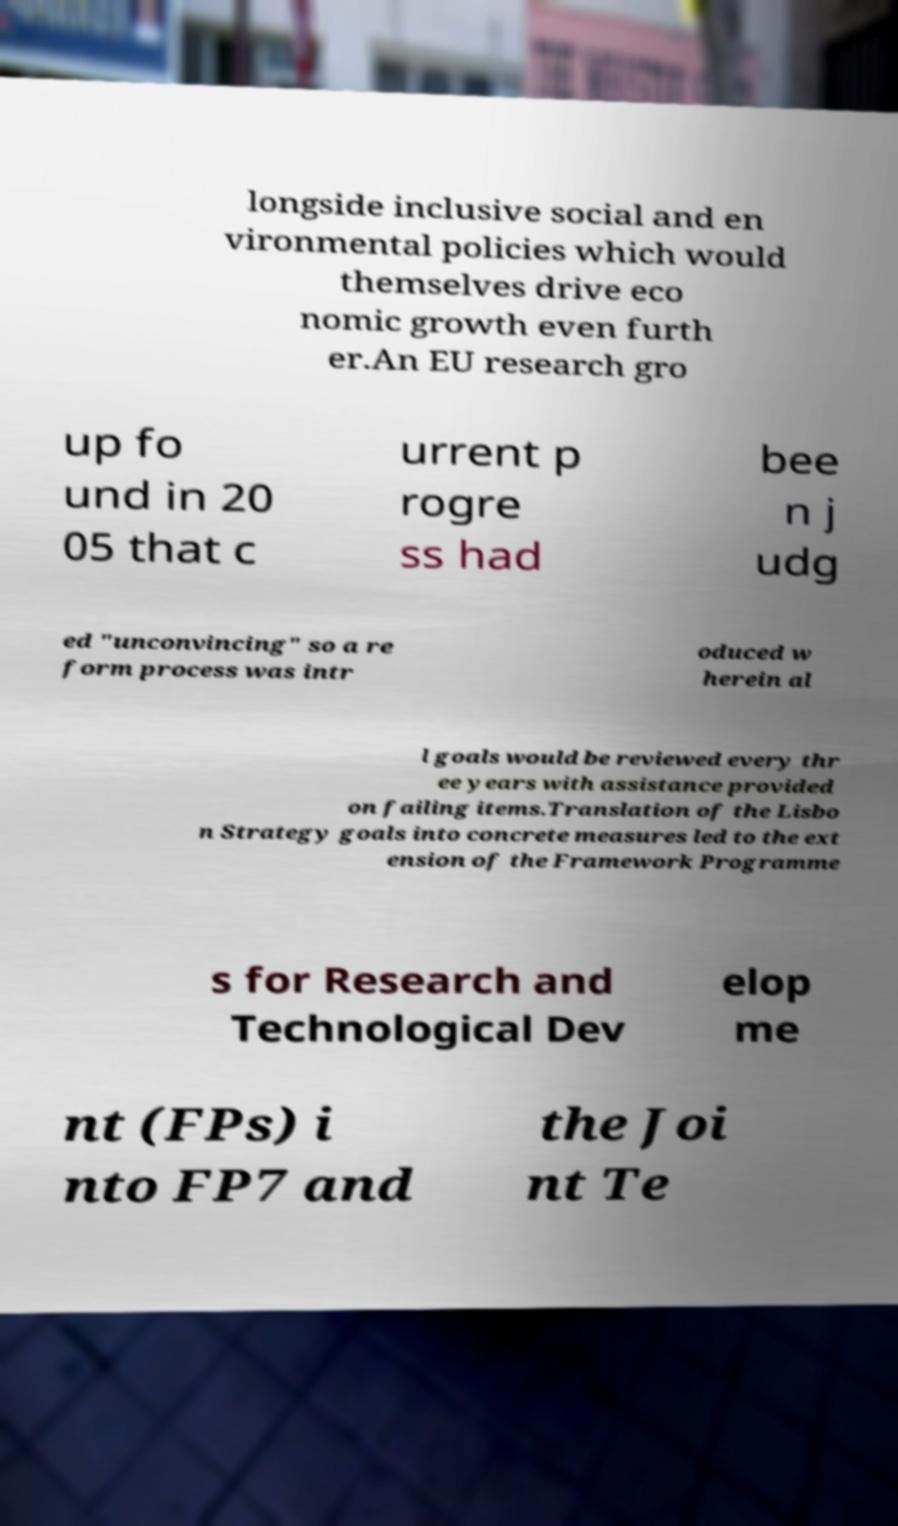I need the written content from this picture converted into text. Can you do that? longside inclusive social and en vironmental policies which would themselves drive eco nomic growth even furth er.An EU research gro up fo und in 20 05 that c urrent p rogre ss had bee n j udg ed "unconvincing" so a re form process was intr oduced w herein al l goals would be reviewed every thr ee years with assistance provided on failing items.Translation of the Lisbo n Strategy goals into concrete measures led to the ext ension of the Framework Programme s for Research and Technological Dev elop me nt (FPs) i nto FP7 and the Joi nt Te 